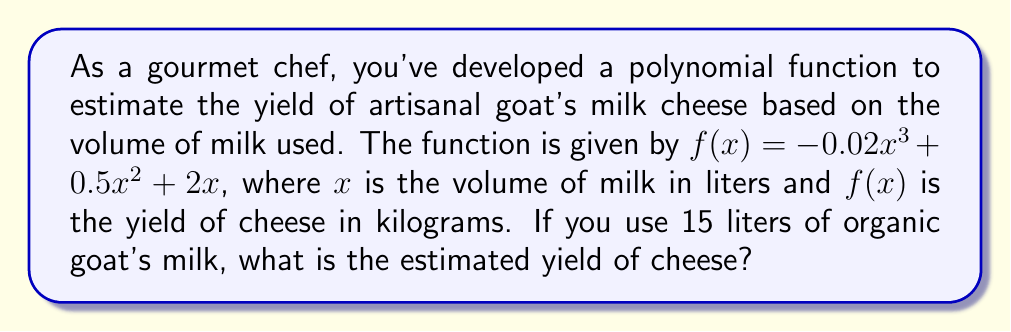Show me your answer to this math problem. To solve this problem, we need to evaluate the function $f(x)$ at $x = 15$. Let's do this step by step:

1) The given function is $f(x) = -0.02x^3 + 0.5x^2 + 2x$

2) We need to calculate $f(15)$, so we substitute $x$ with 15:

   $f(15) = -0.02(15)^3 + 0.5(15)^2 + 2(15)$

3) Let's evaluate each term:
   
   a) $-0.02(15)^3 = -0.02 * 3375 = -67.5$
   
   b) $0.5(15)^2 = 0.5 * 225 = 112.5$
   
   c) $2(15) = 30$

4) Now, we sum these terms:

   $f(15) = -67.5 + 112.5 + 30 = 75$

Therefore, the estimated yield of cheese from 15 liters of goat's milk is 75 kilograms.
Answer: 75 kg 